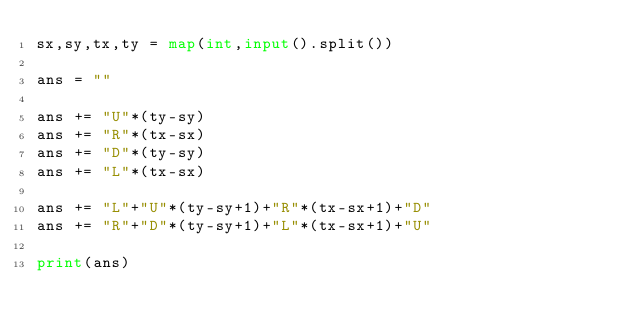Convert code to text. <code><loc_0><loc_0><loc_500><loc_500><_Python_>sx,sy,tx,ty = map(int,input().split())

ans = ""

ans += "U"*(ty-sy)
ans += "R"*(tx-sx)
ans += "D"*(ty-sy)
ans += "L"*(tx-sx)

ans += "L"+"U"*(ty-sy+1)+"R"*(tx-sx+1)+"D"
ans += "R"+"D"*(ty-sy+1)+"L"*(tx-sx+1)+"U"

print(ans)</code> 